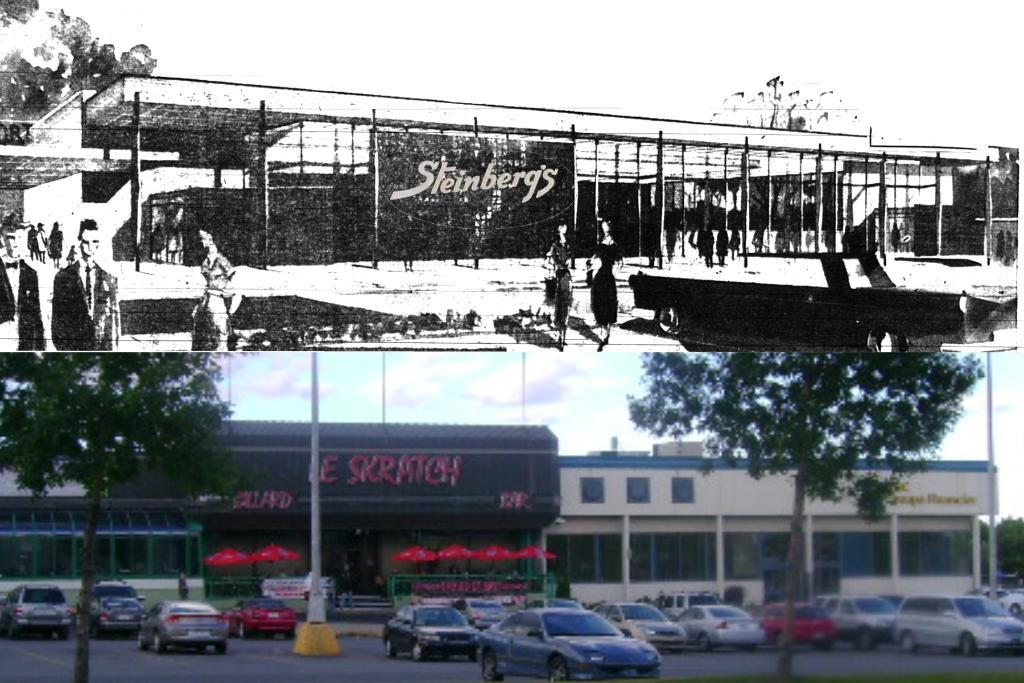What types of objects are located at the bottom of the image? There are cars, trees, buildings, and a pole at the bottom of the image. What can be seen at the top of the image? There is a black and white picture at the top of the image. What color is the tongue of the person in the image? There is no person or tongue present in the image. How does the idea in the image turn into a reality? There is no idea or process of turning it into reality depicted in the image. 